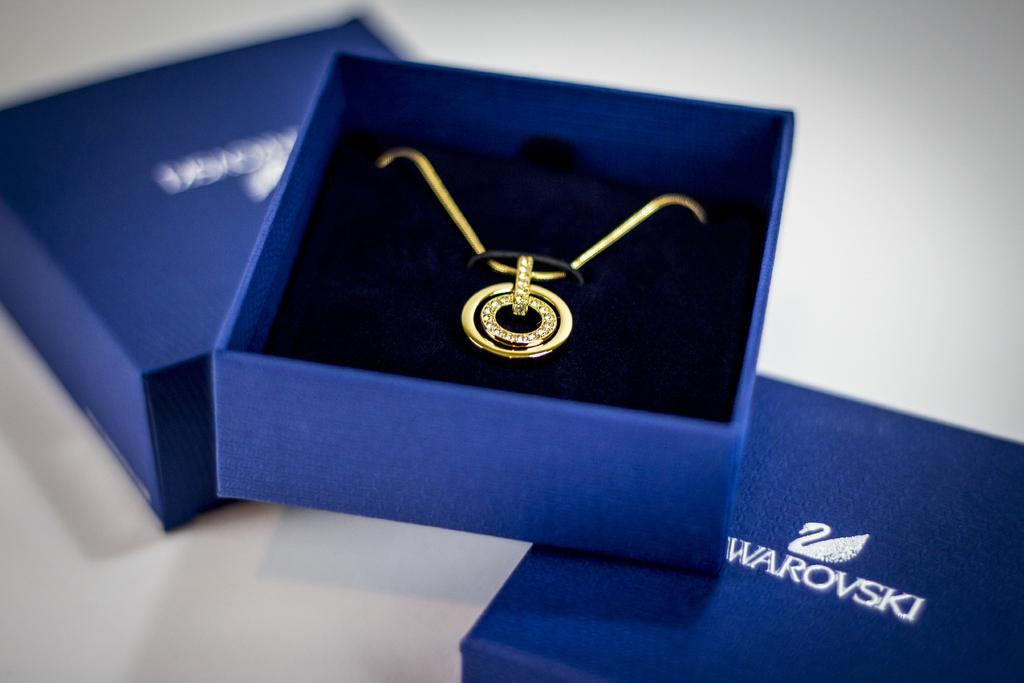<image>
Create a compact narrative representing the image presented. a Swarovski gold and diamond necklace in a blue box 